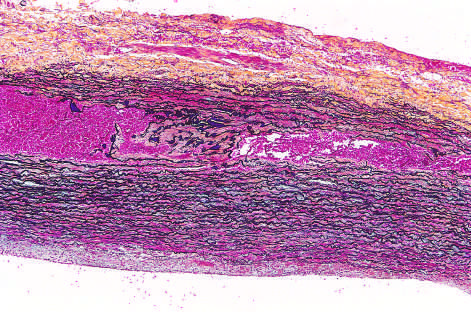what is red in this section, stained with movat stain?
Answer the question using a single word or phrase. Blood 